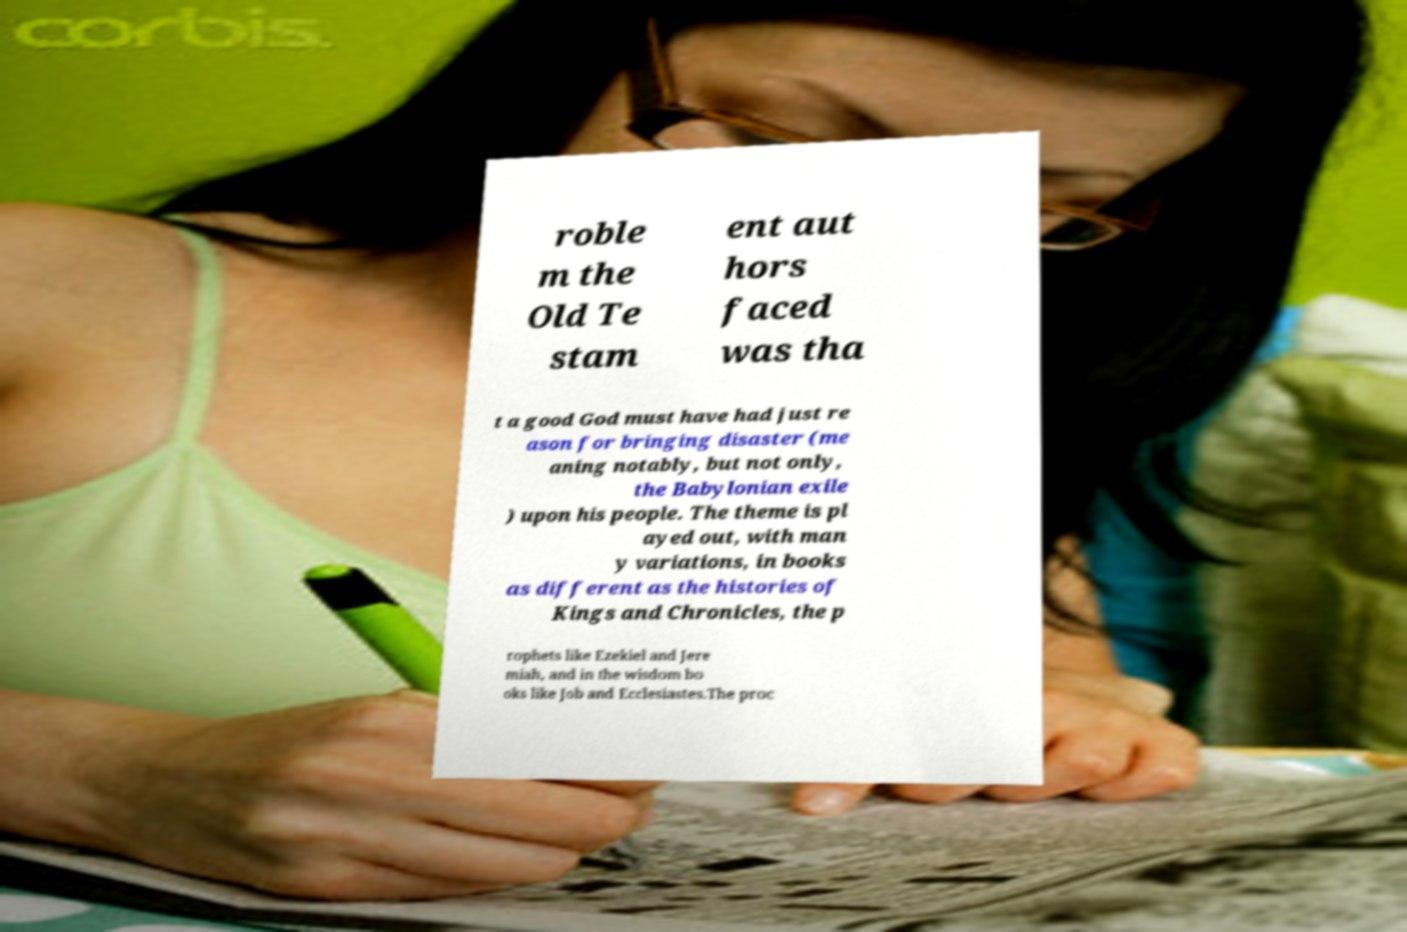I need the written content from this picture converted into text. Can you do that? roble m the Old Te stam ent aut hors faced was tha t a good God must have had just re ason for bringing disaster (me aning notably, but not only, the Babylonian exile ) upon his people. The theme is pl ayed out, with man y variations, in books as different as the histories of Kings and Chronicles, the p rophets like Ezekiel and Jere miah, and in the wisdom bo oks like Job and Ecclesiastes.The proc 